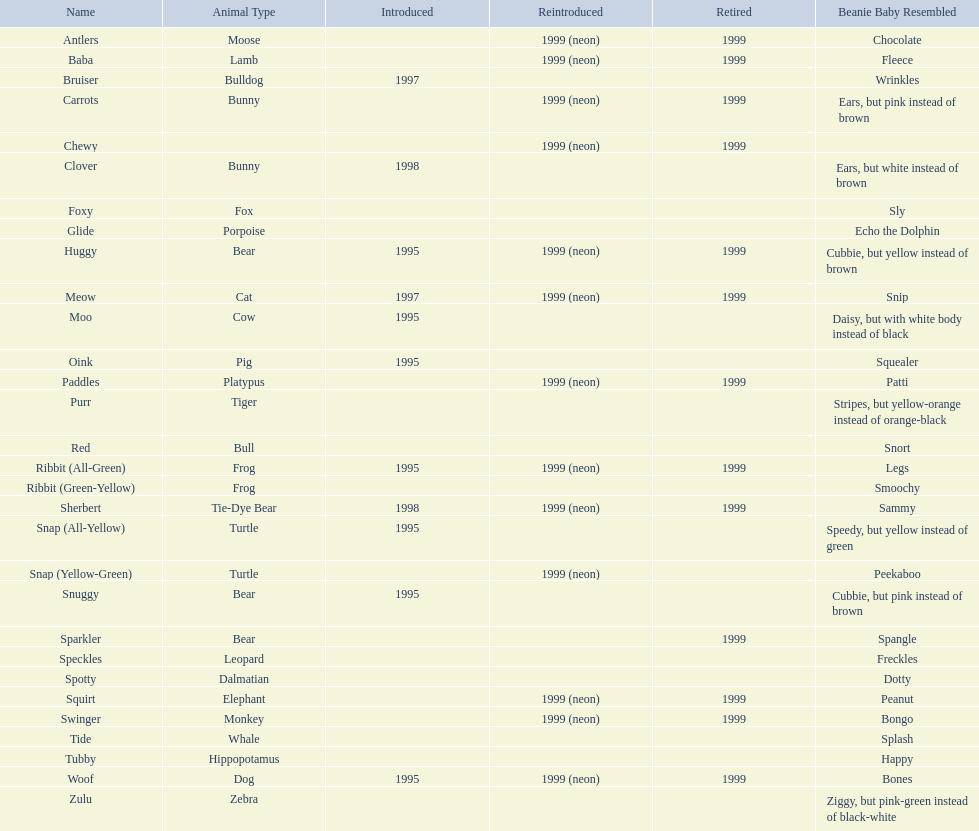What species make up pillow pals? Moose, Lamb, Bulldog, Bunny, Bunny, Fox, Porpoise, Bear, Cat, Cow, Pig, Platypus, Tiger, Bull, Frog, Frog, Tie-Dye Bear, Turtle, Turtle, Bear, Bear, Leopard, Dalmatian, Elephant, Monkey, Whale, Hippopotamus, Dog, Zebra. What is the designation for the dalmatian? Spotty. 